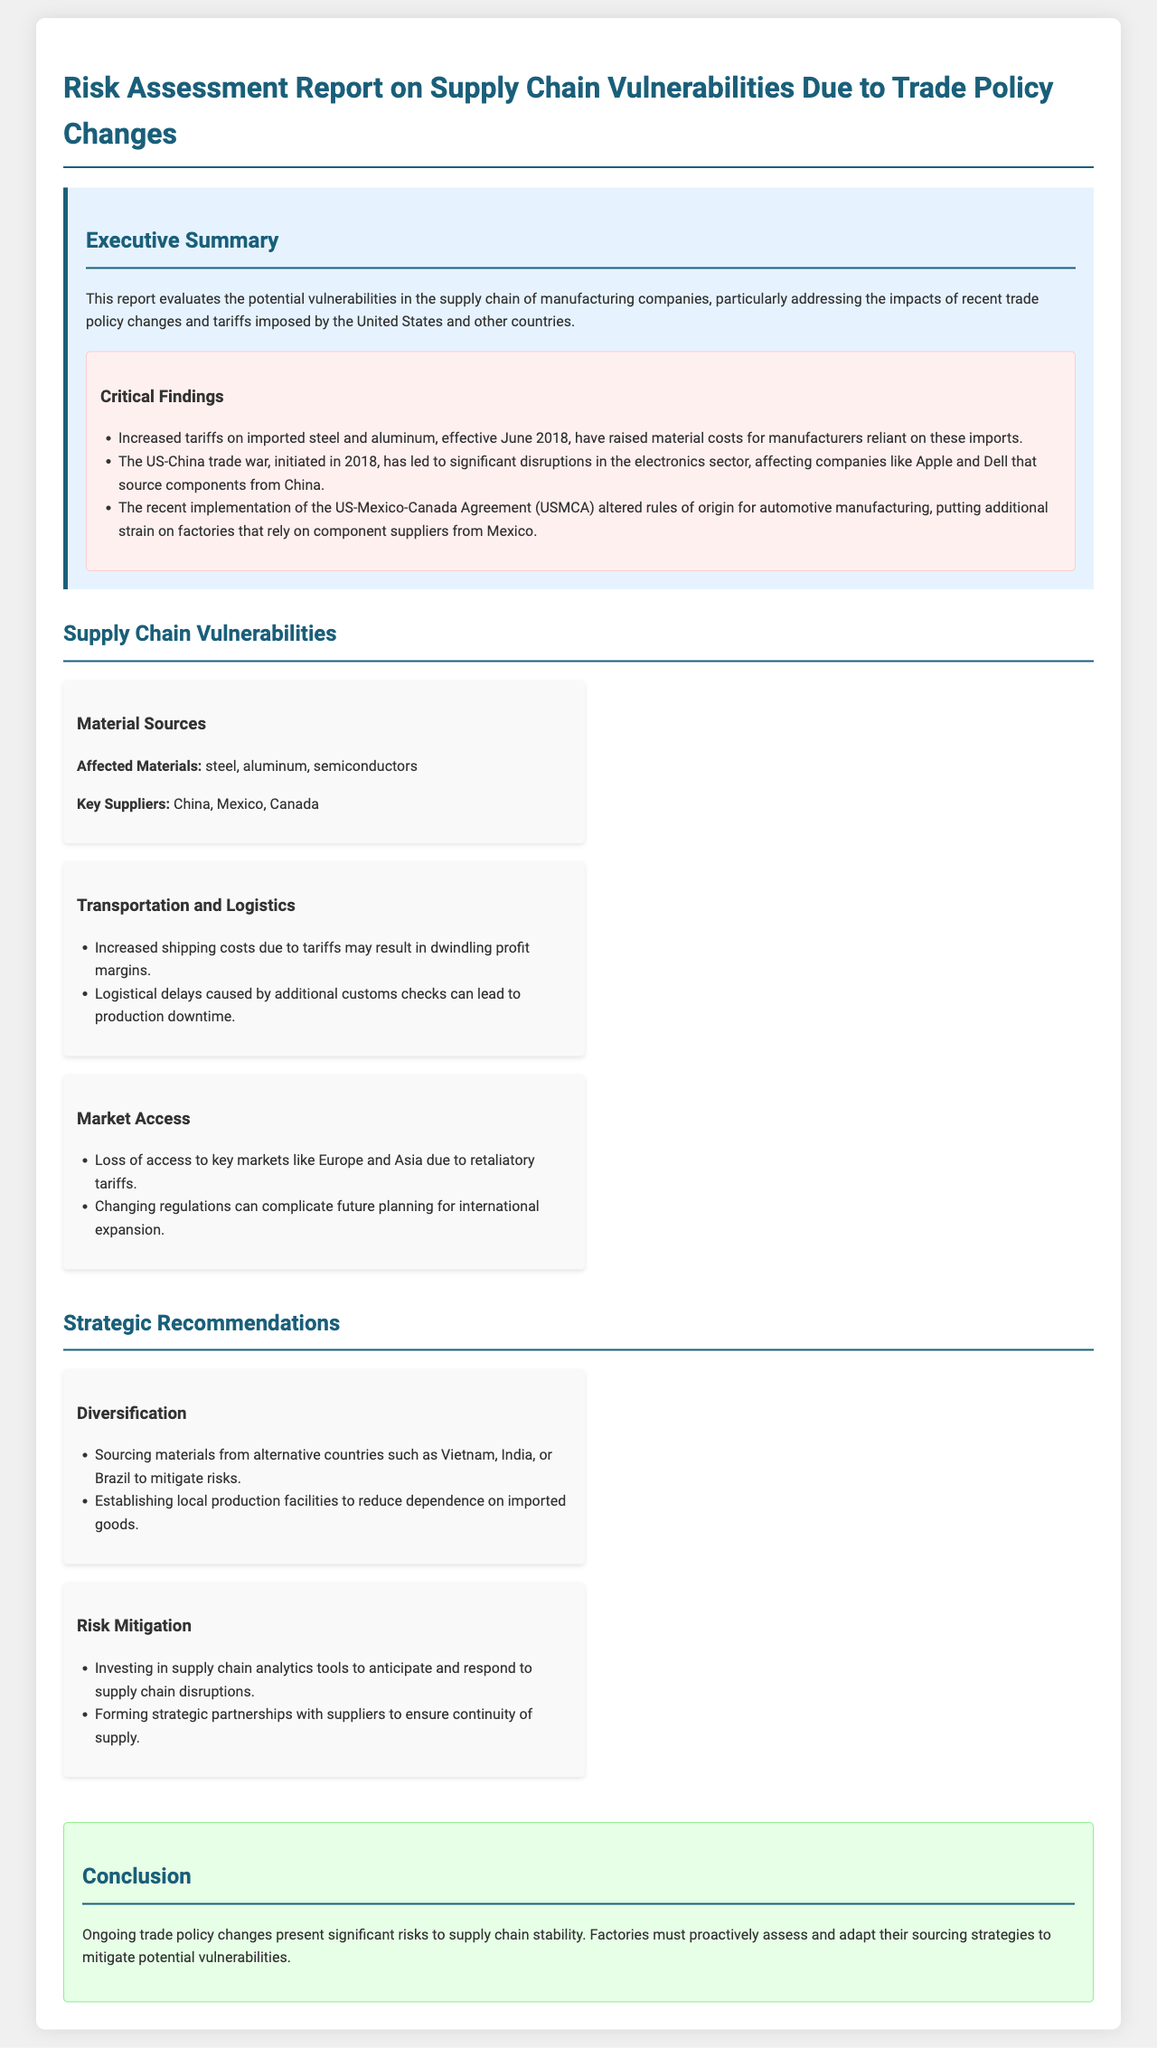What are the critical findings mentioned in the report? The critical findings are listed in a bullet format, summarizing the key impacts of trade policies, such as increased tariffs on imported steel and aluminum.
Answer: Increased tariffs, US-China trade war, USMCA changes What materials are affected according to the supply chain vulnerabilities section? The document specifies affected materials in the vulnerabilities section under "Material Sources."
Answer: Steel, aluminum, semiconductors What countries are mentioned as key suppliers? The report identifies key suppliers in relation to affected materials and trade policies.
Answer: China, Mexico, Canada What is a recommended strategy for sourcing materials? The recommendations suggest diversifying sourcing strategies, emphasizing alternatives to mitigate risks.
Answer: Sourcing from alternative countries What primary risk does increased shipping costs pose? The report discusses the implications of increased shipping costs due to tariffs, specifically how it affects profit margins.
Answer: Dwindling profit margins What is one proposed method for investing in risk mitigation? This recommendation suggests a strategic approach to anticipating supply chain disruptions through technology.
Answer: Supply chain analytics tools What type of trade agreement is mentioned in the report? The document specifically references recent trade agreements that have impacted automotive manufacturing in the report.
Answer: US-Mexico-Canada Agreement (USMCA) What is the conclusion regarding trade policy risks? The conclusion summarizes the overarching theme of the report regarding the need for proactive measures against trade policy changes.
Answer: Significant risks to supply chain stability 